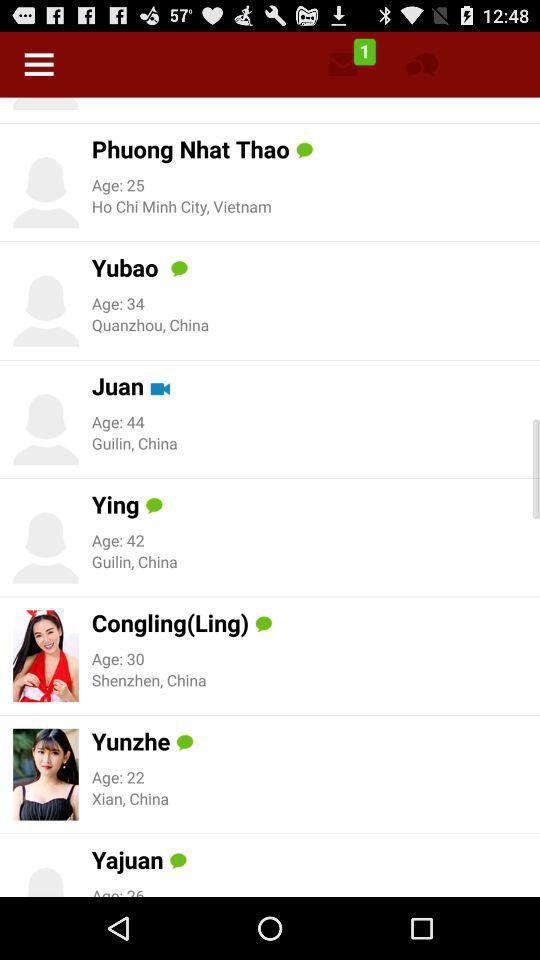Whose age is 22? The person whose age is 22 is Yunzhe. 